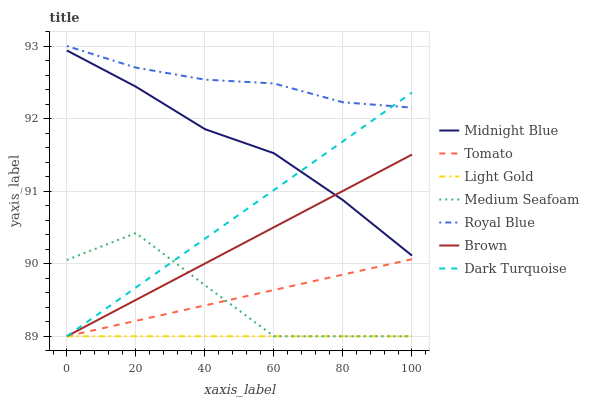Does Light Gold have the minimum area under the curve?
Answer yes or no. Yes. Does Royal Blue have the maximum area under the curve?
Answer yes or no. Yes. Does Brown have the minimum area under the curve?
Answer yes or no. No. Does Brown have the maximum area under the curve?
Answer yes or no. No. Is Brown the smoothest?
Answer yes or no. Yes. Is Medium Seafoam the roughest?
Answer yes or no. Yes. Is Midnight Blue the smoothest?
Answer yes or no. No. Is Midnight Blue the roughest?
Answer yes or no. No. Does Tomato have the lowest value?
Answer yes or no. Yes. Does Midnight Blue have the lowest value?
Answer yes or no. No. Does Royal Blue have the highest value?
Answer yes or no. Yes. Does Brown have the highest value?
Answer yes or no. No. Is Tomato less than Midnight Blue?
Answer yes or no. Yes. Is Royal Blue greater than Midnight Blue?
Answer yes or no. Yes. Does Light Gold intersect Tomato?
Answer yes or no. Yes. Is Light Gold less than Tomato?
Answer yes or no. No. Is Light Gold greater than Tomato?
Answer yes or no. No. Does Tomato intersect Midnight Blue?
Answer yes or no. No. 